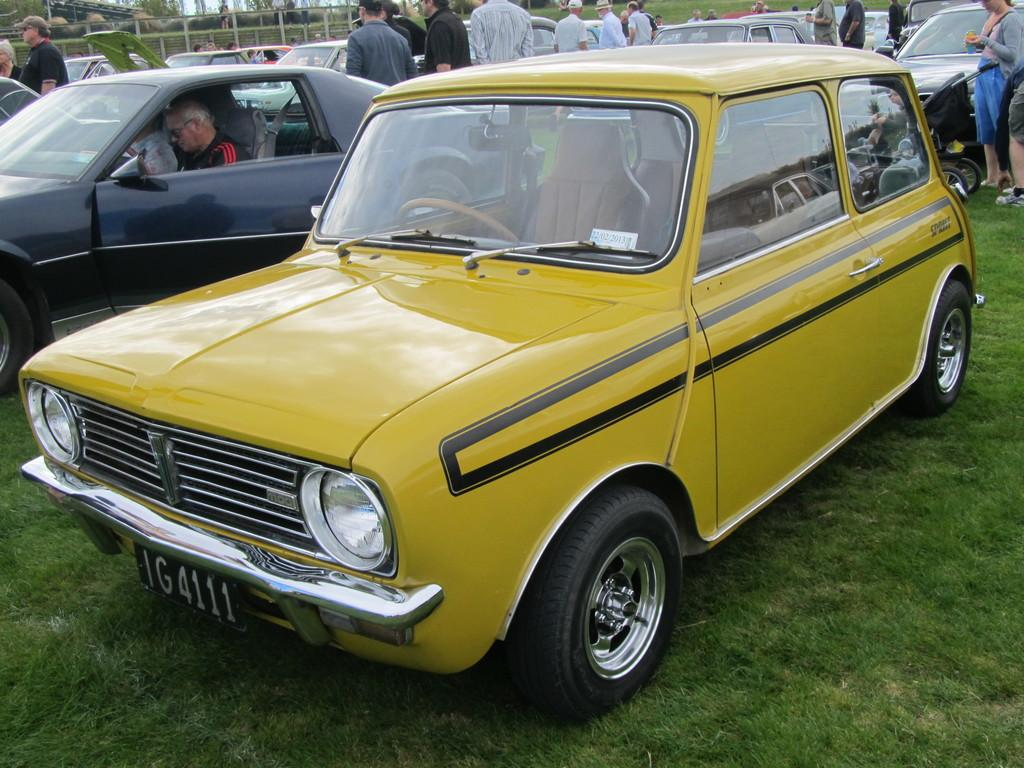What types of objects can be seen in the image? There are vehicles and people in the image. What is the ground surface like in the image? Grass is present at the bottom of the image. What can be seen in the background of the image? There is a fence in the background of the image. What type of suit is the stage wearing in the image? There is no stage or suit present in the image. How many spiders are crawling on the vehicles in the image? There are no spiders visible in the image. 